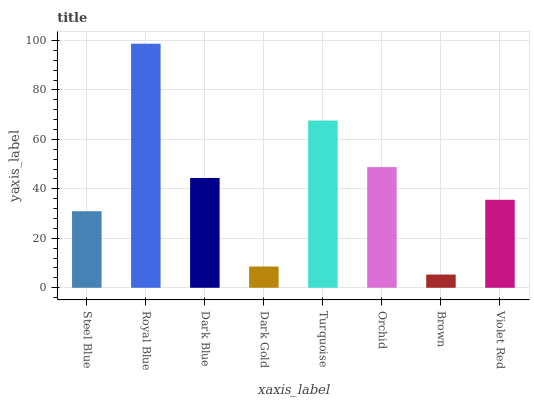Is Brown the minimum?
Answer yes or no. Yes. Is Royal Blue the maximum?
Answer yes or no. Yes. Is Dark Blue the minimum?
Answer yes or no. No. Is Dark Blue the maximum?
Answer yes or no. No. Is Royal Blue greater than Dark Blue?
Answer yes or no. Yes. Is Dark Blue less than Royal Blue?
Answer yes or no. Yes. Is Dark Blue greater than Royal Blue?
Answer yes or no. No. Is Royal Blue less than Dark Blue?
Answer yes or no. No. Is Dark Blue the high median?
Answer yes or no. Yes. Is Violet Red the low median?
Answer yes or no. Yes. Is Royal Blue the high median?
Answer yes or no. No. Is Orchid the low median?
Answer yes or no. No. 